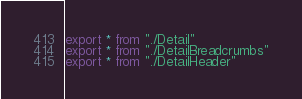Convert code to text. <code><loc_0><loc_0><loc_500><loc_500><_TypeScript_>export * from "./Detail"
export * from "./DetailBreadcrumbs"
export * from "./DetailHeader"
</code> 